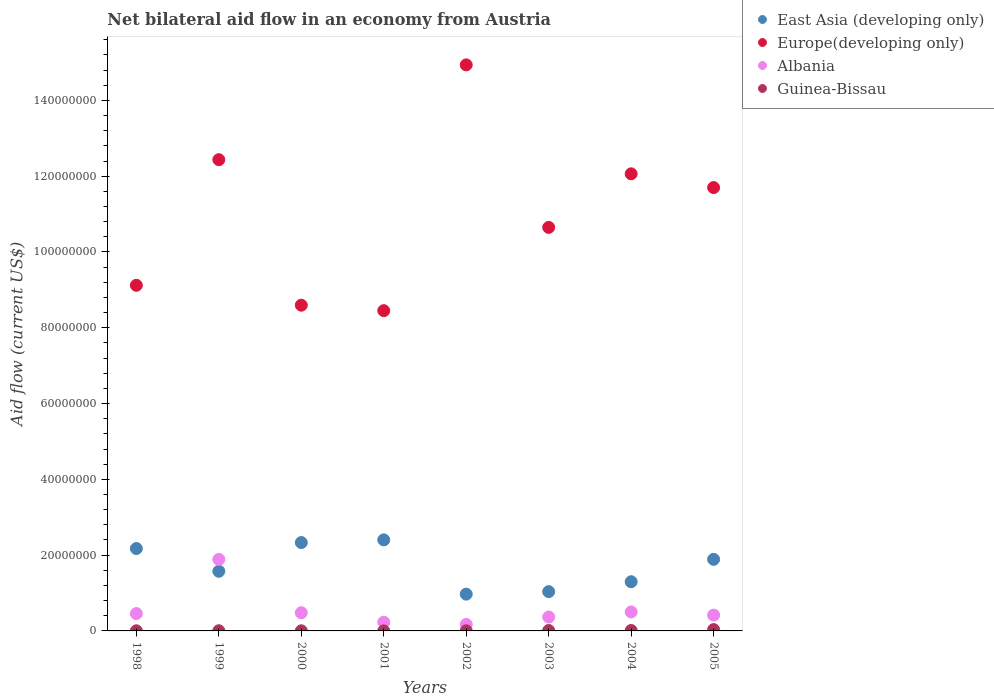How many different coloured dotlines are there?
Give a very brief answer. 4. Is the number of dotlines equal to the number of legend labels?
Ensure brevity in your answer.  Yes. What is the net bilateral aid flow in Guinea-Bissau in 2000?
Give a very brief answer. 3.00e+04. Across all years, what is the maximum net bilateral aid flow in Guinea-Bissau?
Your response must be concise. 3.50e+05. Across all years, what is the minimum net bilateral aid flow in Europe(developing only)?
Ensure brevity in your answer.  8.45e+07. In which year was the net bilateral aid flow in Guinea-Bissau maximum?
Keep it short and to the point. 2005. In which year was the net bilateral aid flow in East Asia (developing only) minimum?
Your answer should be compact. 2002. What is the total net bilateral aid flow in East Asia (developing only) in the graph?
Give a very brief answer. 1.37e+08. What is the difference between the net bilateral aid flow in Albania in 2003 and that in 2004?
Your response must be concise. -1.34e+06. What is the difference between the net bilateral aid flow in East Asia (developing only) in 2004 and the net bilateral aid flow in Europe(developing only) in 2002?
Make the answer very short. -1.36e+08. What is the average net bilateral aid flow in East Asia (developing only) per year?
Your response must be concise. 1.71e+07. In the year 2003, what is the difference between the net bilateral aid flow in Guinea-Bissau and net bilateral aid flow in Albania?
Your answer should be very brief. -3.56e+06. In how many years, is the net bilateral aid flow in East Asia (developing only) greater than 40000000 US$?
Give a very brief answer. 0. What is the ratio of the net bilateral aid flow in Europe(developing only) in 1999 to that in 2005?
Offer a very short reply. 1.06. Is the difference between the net bilateral aid flow in Guinea-Bissau in 2000 and 2001 greater than the difference between the net bilateral aid flow in Albania in 2000 and 2001?
Your answer should be compact. No. What is the difference between the highest and the second highest net bilateral aid flow in East Asia (developing only)?
Provide a short and direct response. 7.10e+05. What is the difference between the highest and the lowest net bilateral aid flow in Albania?
Make the answer very short. 1.72e+07. In how many years, is the net bilateral aid flow in Europe(developing only) greater than the average net bilateral aid flow in Europe(developing only) taken over all years?
Keep it short and to the point. 4. Is the sum of the net bilateral aid flow in Albania in 2001 and 2002 greater than the maximum net bilateral aid flow in East Asia (developing only) across all years?
Ensure brevity in your answer.  No. Is it the case that in every year, the sum of the net bilateral aid flow in East Asia (developing only) and net bilateral aid flow in Europe(developing only)  is greater than the sum of net bilateral aid flow in Guinea-Bissau and net bilateral aid flow in Albania?
Provide a succinct answer. Yes. Is it the case that in every year, the sum of the net bilateral aid flow in Albania and net bilateral aid flow in East Asia (developing only)  is greater than the net bilateral aid flow in Guinea-Bissau?
Make the answer very short. Yes. Does the net bilateral aid flow in Europe(developing only) monotonically increase over the years?
Offer a terse response. No. Is the net bilateral aid flow in Albania strictly greater than the net bilateral aid flow in Europe(developing only) over the years?
Offer a very short reply. No. Is the net bilateral aid flow in Albania strictly less than the net bilateral aid flow in Europe(developing only) over the years?
Ensure brevity in your answer.  Yes. How many years are there in the graph?
Your answer should be compact. 8. What is the difference between two consecutive major ticks on the Y-axis?
Make the answer very short. 2.00e+07. Does the graph contain any zero values?
Offer a very short reply. No. Does the graph contain grids?
Offer a very short reply. No. Where does the legend appear in the graph?
Make the answer very short. Top right. How many legend labels are there?
Your answer should be compact. 4. What is the title of the graph?
Provide a short and direct response. Net bilateral aid flow in an economy from Austria. What is the label or title of the X-axis?
Your answer should be compact. Years. What is the Aid flow (current US$) of East Asia (developing only) in 1998?
Provide a short and direct response. 2.17e+07. What is the Aid flow (current US$) of Europe(developing only) in 1998?
Offer a very short reply. 9.12e+07. What is the Aid flow (current US$) of Albania in 1998?
Provide a succinct answer. 4.58e+06. What is the Aid flow (current US$) of Guinea-Bissau in 1998?
Provide a succinct answer. 3.00e+04. What is the Aid flow (current US$) in East Asia (developing only) in 1999?
Provide a succinct answer. 1.57e+07. What is the Aid flow (current US$) of Europe(developing only) in 1999?
Offer a very short reply. 1.24e+08. What is the Aid flow (current US$) in Albania in 1999?
Offer a very short reply. 1.89e+07. What is the Aid flow (current US$) of Guinea-Bissau in 1999?
Offer a very short reply. 5.00e+04. What is the Aid flow (current US$) of East Asia (developing only) in 2000?
Give a very brief answer. 2.33e+07. What is the Aid flow (current US$) in Europe(developing only) in 2000?
Keep it short and to the point. 8.60e+07. What is the Aid flow (current US$) in Albania in 2000?
Provide a short and direct response. 4.80e+06. What is the Aid flow (current US$) of East Asia (developing only) in 2001?
Your answer should be compact. 2.40e+07. What is the Aid flow (current US$) of Europe(developing only) in 2001?
Provide a short and direct response. 8.45e+07. What is the Aid flow (current US$) in Albania in 2001?
Offer a very short reply. 2.30e+06. What is the Aid flow (current US$) in East Asia (developing only) in 2002?
Your response must be concise. 9.71e+06. What is the Aid flow (current US$) of Europe(developing only) in 2002?
Your answer should be compact. 1.49e+08. What is the Aid flow (current US$) of Albania in 2002?
Keep it short and to the point. 1.71e+06. What is the Aid flow (current US$) of East Asia (developing only) in 2003?
Your answer should be compact. 1.04e+07. What is the Aid flow (current US$) of Europe(developing only) in 2003?
Provide a short and direct response. 1.06e+08. What is the Aid flow (current US$) in Albania in 2003?
Offer a terse response. 3.67e+06. What is the Aid flow (current US$) in Guinea-Bissau in 2003?
Your response must be concise. 1.10e+05. What is the Aid flow (current US$) of East Asia (developing only) in 2004?
Keep it short and to the point. 1.30e+07. What is the Aid flow (current US$) in Europe(developing only) in 2004?
Offer a terse response. 1.21e+08. What is the Aid flow (current US$) of Albania in 2004?
Keep it short and to the point. 5.01e+06. What is the Aid flow (current US$) of East Asia (developing only) in 2005?
Your response must be concise. 1.89e+07. What is the Aid flow (current US$) in Europe(developing only) in 2005?
Keep it short and to the point. 1.17e+08. What is the Aid flow (current US$) in Albania in 2005?
Your answer should be very brief. 4.18e+06. Across all years, what is the maximum Aid flow (current US$) of East Asia (developing only)?
Provide a short and direct response. 2.40e+07. Across all years, what is the maximum Aid flow (current US$) in Europe(developing only)?
Give a very brief answer. 1.49e+08. Across all years, what is the maximum Aid flow (current US$) of Albania?
Provide a succinct answer. 1.89e+07. Across all years, what is the minimum Aid flow (current US$) of East Asia (developing only)?
Offer a terse response. 9.71e+06. Across all years, what is the minimum Aid flow (current US$) in Europe(developing only)?
Make the answer very short. 8.45e+07. Across all years, what is the minimum Aid flow (current US$) of Albania?
Provide a succinct answer. 1.71e+06. What is the total Aid flow (current US$) in East Asia (developing only) in the graph?
Provide a succinct answer. 1.37e+08. What is the total Aid flow (current US$) of Europe(developing only) in the graph?
Provide a short and direct response. 8.80e+08. What is the total Aid flow (current US$) of Albania in the graph?
Your response must be concise. 4.51e+07. What is the total Aid flow (current US$) in Guinea-Bissau in the graph?
Your answer should be very brief. 7.30e+05. What is the difference between the Aid flow (current US$) in East Asia (developing only) in 1998 and that in 1999?
Keep it short and to the point. 6.00e+06. What is the difference between the Aid flow (current US$) in Europe(developing only) in 1998 and that in 1999?
Provide a short and direct response. -3.32e+07. What is the difference between the Aid flow (current US$) of Albania in 1998 and that in 1999?
Your answer should be compact. -1.43e+07. What is the difference between the Aid flow (current US$) in East Asia (developing only) in 1998 and that in 2000?
Ensure brevity in your answer.  -1.58e+06. What is the difference between the Aid flow (current US$) in Europe(developing only) in 1998 and that in 2000?
Offer a very short reply. 5.25e+06. What is the difference between the Aid flow (current US$) of East Asia (developing only) in 1998 and that in 2001?
Keep it short and to the point. -2.29e+06. What is the difference between the Aid flow (current US$) in Europe(developing only) in 1998 and that in 2001?
Your answer should be very brief. 6.69e+06. What is the difference between the Aid flow (current US$) of Albania in 1998 and that in 2001?
Make the answer very short. 2.28e+06. What is the difference between the Aid flow (current US$) in Guinea-Bissau in 1998 and that in 2001?
Keep it short and to the point. 10000. What is the difference between the Aid flow (current US$) in East Asia (developing only) in 1998 and that in 2002?
Keep it short and to the point. 1.20e+07. What is the difference between the Aid flow (current US$) in Europe(developing only) in 1998 and that in 2002?
Provide a short and direct response. -5.82e+07. What is the difference between the Aid flow (current US$) of Albania in 1998 and that in 2002?
Your answer should be very brief. 2.87e+06. What is the difference between the Aid flow (current US$) of East Asia (developing only) in 1998 and that in 2003?
Provide a succinct answer. 1.14e+07. What is the difference between the Aid flow (current US$) of Europe(developing only) in 1998 and that in 2003?
Provide a short and direct response. -1.53e+07. What is the difference between the Aid flow (current US$) of Albania in 1998 and that in 2003?
Offer a very short reply. 9.10e+05. What is the difference between the Aid flow (current US$) in East Asia (developing only) in 1998 and that in 2004?
Ensure brevity in your answer.  8.76e+06. What is the difference between the Aid flow (current US$) of Europe(developing only) in 1998 and that in 2004?
Your response must be concise. -2.94e+07. What is the difference between the Aid flow (current US$) of Albania in 1998 and that in 2004?
Give a very brief answer. -4.30e+05. What is the difference between the Aid flow (current US$) in Guinea-Bissau in 1998 and that in 2004?
Give a very brief answer. -8.00e+04. What is the difference between the Aid flow (current US$) of East Asia (developing only) in 1998 and that in 2005?
Ensure brevity in your answer.  2.85e+06. What is the difference between the Aid flow (current US$) in Europe(developing only) in 1998 and that in 2005?
Give a very brief answer. -2.58e+07. What is the difference between the Aid flow (current US$) in Albania in 1998 and that in 2005?
Provide a short and direct response. 4.00e+05. What is the difference between the Aid flow (current US$) in Guinea-Bissau in 1998 and that in 2005?
Ensure brevity in your answer.  -3.20e+05. What is the difference between the Aid flow (current US$) of East Asia (developing only) in 1999 and that in 2000?
Ensure brevity in your answer.  -7.58e+06. What is the difference between the Aid flow (current US$) in Europe(developing only) in 1999 and that in 2000?
Your answer should be compact. 3.84e+07. What is the difference between the Aid flow (current US$) of Albania in 1999 and that in 2000?
Your answer should be very brief. 1.41e+07. What is the difference between the Aid flow (current US$) of East Asia (developing only) in 1999 and that in 2001?
Your answer should be compact. -8.29e+06. What is the difference between the Aid flow (current US$) of Europe(developing only) in 1999 and that in 2001?
Make the answer very short. 3.98e+07. What is the difference between the Aid flow (current US$) of Albania in 1999 and that in 2001?
Make the answer very short. 1.66e+07. What is the difference between the Aid flow (current US$) of Guinea-Bissau in 1999 and that in 2001?
Make the answer very short. 3.00e+04. What is the difference between the Aid flow (current US$) in East Asia (developing only) in 1999 and that in 2002?
Provide a short and direct response. 6.03e+06. What is the difference between the Aid flow (current US$) in Europe(developing only) in 1999 and that in 2002?
Your answer should be compact. -2.50e+07. What is the difference between the Aid flow (current US$) of Albania in 1999 and that in 2002?
Your response must be concise. 1.72e+07. What is the difference between the Aid flow (current US$) in Guinea-Bissau in 1999 and that in 2002?
Your answer should be compact. 2.00e+04. What is the difference between the Aid flow (current US$) of East Asia (developing only) in 1999 and that in 2003?
Give a very brief answer. 5.37e+06. What is the difference between the Aid flow (current US$) in Europe(developing only) in 1999 and that in 2003?
Offer a terse response. 1.79e+07. What is the difference between the Aid flow (current US$) of Albania in 1999 and that in 2003?
Keep it short and to the point. 1.52e+07. What is the difference between the Aid flow (current US$) of Guinea-Bissau in 1999 and that in 2003?
Give a very brief answer. -6.00e+04. What is the difference between the Aid flow (current US$) in East Asia (developing only) in 1999 and that in 2004?
Ensure brevity in your answer.  2.76e+06. What is the difference between the Aid flow (current US$) of Europe(developing only) in 1999 and that in 2004?
Offer a very short reply. 3.73e+06. What is the difference between the Aid flow (current US$) of Albania in 1999 and that in 2004?
Ensure brevity in your answer.  1.39e+07. What is the difference between the Aid flow (current US$) of East Asia (developing only) in 1999 and that in 2005?
Provide a short and direct response. -3.15e+06. What is the difference between the Aid flow (current US$) in Europe(developing only) in 1999 and that in 2005?
Your response must be concise. 7.36e+06. What is the difference between the Aid flow (current US$) in Albania in 1999 and that in 2005?
Keep it short and to the point. 1.47e+07. What is the difference between the Aid flow (current US$) of Guinea-Bissau in 1999 and that in 2005?
Give a very brief answer. -3.00e+05. What is the difference between the Aid flow (current US$) in East Asia (developing only) in 2000 and that in 2001?
Make the answer very short. -7.10e+05. What is the difference between the Aid flow (current US$) in Europe(developing only) in 2000 and that in 2001?
Offer a very short reply. 1.44e+06. What is the difference between the Aid flow (current US$) in Albania in 2000 and that in 2001?
Your answer should be very brief. 2.50e+06. What is the difference between the Aid flow (current US$) of Guinea-Bissau in 2000 and that in 2001?
Keep it short and to the point. 10000. What is the difference between the Aid flow (current US$) of East Asia (developing only) in 2000 and that in 2002?
Your response must be concise. 1.36e+07. What is the difference between the Aid flow (current US$) of Europe(developing only) in 2000 and that in 2002?
Give a very brief answer. -6.34e+07. What is the difference between the Aid flow (current US$) of Albania in 2000 and that in 2002?
Your response must be concise. 3.09e+06. What is the difference between the Aid flow (current US$) in Guinea-Bissau in 2000 and that in 2002?
Your answer should be compact. 0. What is the difference between the Aid flow (current US$) of East Asia (developing only) in 2000 and that in 2003?
Ensure brevity in your answer.  1.30e+07. What is the difference between the Aid flow (current US$) of Europe(developing only) in 2000 and that in 2003?
Provide a succinct answer. -2.05e+07. What is the difference between the Aid flow (current US$) in Albania in 2000 and that in 2003?
Your response must be concise. 1.13e+06. What is the difference between the Aid flow (current US$) in Guinea-Bissau in 2000 and that in 2003?
Keep it short and to the point. -8.00e+04. What is the difference between the Aid flow (current US$) in East Asia (developing only) in 2000 and that in 2004?
Provide a short and direct response. 1.03e+07. What is the difference between the Aid flow (current US$) in Europe(developing only) in 2000 and that in 2004?
Provide a short and direct response. -3.47e+07. What is the difference between the Aid flow (current US$) in Guinea-Bissau in 2000 and that in 2004?
Keep it short and to the point. -8.00e+04. What is the difference between the Aid flow (current US$) in East Asia (developing only) in 2000 and that in 2005?
Keep it short and to the point. 4.43e+06. What is the difference between the Aid flow (current US$) of Europe(developing only) in 2000 and that in 2005?
Offer a terse response. -3.10e+07. What is the difference between the Aid flow (current US$) in Albania in 2000 and that in 2005?
Keep it short and to the point. 6.20e+05. What is the difference between the Aid flow (current US$) of Guinea-Bissau in 2000 and that in 2005?
Ensure brevity in your answer.  -3.20e+05. What is the difference between the Aid flow (current US$) in East Asia (developing only) in 2001 and that in 2002?
Give a very brief answer. 1.43e+07. What is the difference between the Aid flow (current US$) of Europe(developing only) in 2001 and that in 2002?
Offer a very short reply. -6.49e+07. What is the difference between the Aid flow (current US$) in Albania in 2001 and that in 2002?
Give a very brief answer. 5.90e+05. What is the difference between the Aid flow (current US$) of Guinea-Bissau in 2001 and that in 2002?
Offer a very short reply. -10000. What is the difference between the Aid flow (current US$) of East Asia (developing only) in 2001 and that in 2003?
Ensure brevity in your answer.  1.37e+07. What is the difference between the Aid flow (current US$) of Europe(developing only) in 2001 and that in 2003?
Give a very brief answer. -2.20e+07. What is the difference between the Aid flow (current US$) in Albania in 2001 and that in 2003?
Your answer should be very brief. -1.37e+06. What is the difference between the Aid flow (current US$) in East Asia (developing only) in 2001 and that in 2004?
Provide a succinct answer. 1.10e+07. What is the difference between the Aid flow (current US$) of Europe(developing only) in 2001 and that in 2004?
Provide a succinct answer. -3.61e+07. What is the difference between the Aid flow (current US$) of Albania in 2001 and that in 2004?
Provide a short and direct response. -2.71e+06. What is the difference between the Aid flow (current US$) of Guinea-Bissau in 2001 and that in 2004?
Your answer should be very brief. -9.00e+04. What is the difference between the Aid flow (current US$) of East Asia (developing only) in 2001 and that in 2005?
Your answer should be very brief. 5.14e+06. What is the difference between the Aid flow (current US$) of Europe(developing only) in 2001 and that in 2005?
Keep it short and to the point. -3.25e+07. What is the difference between the Aid flow (current US$) in Albania in 2001 and that in 2005?
Ensure brevity in your answer.  -1.88e+06. What is the difference between the Aid flow (current US$) in Guinea-Bissau in 2001 and that in 2005?
Make the answer very short. -3.30e+05. What is the difference between the Aid flow (current US$) in East Asia (developing only) in 2002 and that in 2003?
Your response must be concise. -6.60e+05. What is the difference between the Aid flow (current US$) of Europe(developing only) in 2002 and that in 2003?
Your answer should be very brief. 4.29e+07. What is the difference between the Aid flow (current US$) in Albania in 2002 and that in 2003?
Your answer should be very brief. -1.96e+06. What is the difference between the Aid flow (current US$) in East Asia (developing only) in 2002 and that in 2004?
Your response must be concise. -3.27e+06. What is the difference between the Aid flow (current US$) in Europe(developing only) in 2002 and that in 2004?
Ensure brevity in your answer.  2.88e+07. What is the difference between the Aid flow (current US$) of Albania in 2002 and that in 2004?
Make the answer very short. -3.30e+06. What is the difference between the Aid flow (current US$) in East Asia (developing only) in 2002 and that in 2005?
Provide a succinct answer. -9.18e+06. What is the difference between the Aid flow (current US$) of Europe(developing only) in 2002 and that in 2005?
Give a very brief answer. 3.24e+07. What is the difference between the Aid flow (current US$) in Albania in 2002 and that in 2005?
Ensure brevity in your answer.  -2.47e+06. What is the difference between the Aid flow (current US$) in Guinea-Bissau in 2002 and that in 2005?
Your answer should be very brief. -3.20e+05. What is the difference between the Aid flow (current US$) of East Asia (developing only) in 2003 and that in 2004?
Your answer should be compact. -2.61e+06. What is the difference between the Aid flow (current US$) in Europe(developing only) in 2003 and that in 2004?
Keep it short and to the point. -1.41e+07. What is the difference between the Aid flow (current US$) of Albania in 2003 and that in 2004?
Make the answer very short. -1.34e+06. What is the difference between the Aid flow (current US$) in East Asia (developing only) in 2003 and that in 2005?
Offer a very short reply. -8.52e+06. What is the difference between the Aid flow (current US$) in Europe(developing only) in 2003 and that in 2005?
Make the answer very short. -1.05e+07. What is the difference between the Aid flow (current US$) of Albania in 2003 and that in 2005?
Provide a short and direct response. -5.10e+05. What is the difference between the Aid flow (current US$) of Guinea-Bissau in 2003 and that in 2005?
Offer a very short reply. -2.40e+05. What is the difference between the Aid flow (current US$) in East Asia (developing only) in 2004 and that in 2005?
Ensure brevity in your answer.  -5.91e+06. What is the difference between the Aid flow (current US$) in Europe(developing only) in 2004 and that in 2005?
Offer a terse response. 3.63e+06. What is the difference between the Aid flow (current US$) of Albania in 2004 and that in 2005?
Provide a short and direct response. 8.30e+05. What is the difference between the Aid flow (current US$) of Guinea-Bissau in 2004 and that in 2005?
Offer a terse response. -2.40e+05. What is the difference between the Aid flow (current US$) of East Asia (developing only) in 1998 and the Aid flow (current US$) of Europe(developing only) in 1999?
Offer a very short reply. -1.03e+08. What is the difference between the Aid flow (current US$) in East Asia (developing only) in 1998 and the Aid flow (current US$) in Albania in 1999?
Offer a terse response. 2.86e+06. What is the difference between the Aid flow (current US$) in East Asia (developing only) in 1998 and the Aid flow (current US$) in Guinea-Bissau in 1999?
Ensure brevity in your answer.  2.17e+07. What is the difference between the Aid flow (current US$) in Europe(developing only) in 1998 and the Aid flow (current US$) in Albania in 1999?
Your answer should be very brief. 7.23e+07. What is the difference between the Aid flow (current US$) in Europe(developing only) in 1998 and the Aid flow (current US$) in Guinea-Bissau in 1999?
Your answer should be compact. 9.12e+07. What is the difference between the Aid flow (current US$) in Albania in 1998 and the Aid flow (current US$) in Guinea-Bissau in 1999?
Your answer should be compact. 4.53e+06. What is the difference between the Aid flow (current US$) of East Asia (developing only) in 1998 and the Aid flow (current US$) of Europe(developing only) in 2000?
Give a very brief answer. -6.42e+07. What is the difference between the Aid flow (current US$) in East Asia (developing only) in 1998 and the Aid flow (current US$) in Albania in 2000?
Give a very brief answer. 1.69e+07. What is the difference between the Aid flow (current US$) in East Asia (developing only) in 1998 and the Aid flow (current US$) in Guinea-Bissau in 2000?
Provide a succinct answer. 2.17e+07. What is the difference between the Aid flow (current US$) of Europe(developing only) in 1998 and the Aid flow (current US$) of Albania in 2000?
Provide a short and direct response. 8.64e+07. What is the difference between the Aid flow (current US$) of Europe(developing only) in 1998 and the Aid flow (current US$) of Guinea-Bissau in 2000?
Make the answer very short. 9.12e+07. What is the difference between the Aid flow (current US$) of Albania in 1998 and the Aid flow (current US$) of Guinea-Bissau in 2000?
Your answer should be compact. 4.55e+06. What is the difference between the Aid flow (current US$) in East Asia (developing only) in 1998 and the Aid flow (current US$) in Europe(developing only) in 2001?
Ensure brevity in your answer.  -6.28e+07. What is the difference between the Aid flow (current US$) of East Asia (developing only) in 1998 and the Aid flow (current US$) of Albania in 2001?
Give a very brief answer. 1.94e+07. What is the difference between the Aid flow (current US$) in East Asia (developing only) in 1998 and the Aid flow (current US$) in Guinea-Bissau in 2001?
Keep it short and to the point. 2.17e+07. What is the difference between the Aid flow (current US$) in Europe(developing only) in 1998 and the Aid flow (current US$) in Albania in 2001?
Your answer should be very brief. 8.89e+07. What is the difference between the Aid flow (current US$) in Europe(developing only) in 1998 and the Aid flow (current US$) in Guinea-Bissau in 2001?
Offer a very short reply. 9.12e+07. What is the difference between the Aid flow (current US$) in Albania in 1998 and the Aid flow (current US$) in Guinea-Bissau in 2001?
Make the answer very short. 4.56e+06. What is the difference between the Aid flow (current US$) in East Asia (developing only) in 1998 and the Aid flow (current US$) in Europe(developing only) in 2002?
Keep it short and to the point. -1.28e+08. What is the difference between the Aid flow (current US$) in East Asia (developing only) in 1998 and the Aid flow (current US$) in Albania in 2002?
Ensure brevity in your answer.  2.00e+07. What is the difference between the Aid flow (current US$) of East Asia (developing only) in 1998 and the Aid flow (current US$) of Guinea-Bissau in 2002?
Your answer should be compact. 2.17e+07. What is the difference between the Aid flow (current US$) in Europe(developing only) in 1998 and the Aid flow (current US$) in Albania in 2002?
Offer a terse response. 8.95e+07. What is the difference between the Aid flow (current US$) in Europe(developing only) in 1998 and the Aid flow (current US$) in Guinea-Bissau in 2002?
Ensure brevity in your answer.  9.12e+07. What is the difference between the Aid flow (current US$) in Albania in 1998 and the Aid flow (current US$) in Guinea-Bissau in 2002?
Your answer should be very brief. 4.55e+06. What is the difference between the Aid flow (current US$) of East Asia (developing only) in 1998 and the Aid flow (current US$) of Europe(developing only) in 2003?
Offer a terse response. -8.48e+07. What is the difference between the Aid flow (current US$) in East Asia (developing only) in 1998 and the Aid flow (current US$) in Albania in 2003?
Offer a terse response. 1.81e+07. What is the difference between the Aid flow (current US$) in East Asia (developing only) in 1998 and the Aid flow (current US$) in Guinea-Bissau in 2003?
Provide a succinct answer. 2.16e+07. What is the difference between the Aid flow (current US$) of Europe(developing only) in 1998 and the Aid flow (current US$) of Albania in 2003?
Your response must be concise. 8.75e+07. What is the difference between the Aid flow (current US$) in Europe(developing only) in 1998 and the Aid flow (current US$) in Guinea-Bissau in 2003?
Provide a short and direct response. 9.11e+07. What is the difference between the Aid flow (current US$) in Albania in 1998 and the Aid flow (current US$) in Guinea-Bissau in 2003?
Provide a short and direct response. 4.47e+06. What is the difference between the Aid flow (current US$) of East Asia (developing only) in 1998 and the Aid flow (current US$) of Europe(developing only) in 2004?
Give a very brief answer. -9.89e+07. What is the difference between the Aid flow (current US$) of East Asia (developing only) in 1998 and the Aid flow (current US$) of Albania in 2004?
Your answer should be compact. 1.67e+07. What is the difference between the Aid flow (current US$) of East Asia (developing only) in 1998 and the Aid flow (current US$) of Guinea-Bissau in 2004?
Your answer should be very brief. 2.16e+07. What is the difference between the Aid flow (current US$) of Europe(developing only) in 1998 and the Aid flow (current US$) of Albania in 2004?
Your response must be concise. 8.62e+07. What is the difference between the Aid flow (current US$) in Europe(developing only) in 1998 and the Aid flow (current US$) in Guinea-Bissau in 2004?
Offer a very short reply. 9.11e+07. What is the difference between the Aid flow (current US$) in Albania in 1998 and the Aid flow (current US$) in Guinea-Bissau in 2004?
Provide a succinct answer. 4.47e+06. What is the difference between the Aid flow (current US$) of East Asia (developing only) in 1998 and the Aid flow (current US$) of Europe(developing only) in 2005?
Your response must be concise. -9.53e+07. What is the difference between the Aid flow (current US$) in East Asia (developing only) in 1998 and the Aid flow (current US$) in Albania in 2005?
Your answer should be compact. 1.76e+07. What is the difference between the Aid flow (current US$) in East Asia (developing only) in 1998 and the Aid flow (current US$) in Guinea-Bissau in 2005?
Provide a succinct answer. 2.14e+07. What is the difference between the Aid flow (current US$) of Europe(developing only) in 1998 and the Aid flow (current US$) of Albania in 2005?
Your response must be concise. 8.70e+07. What is the difference between the Aid flow (current US$) of Europe(developing only) in 1998 and the Aid flow (current US$) of Guinea-Bissau in 2005?
Provide a short and direct response. 9.09e+07. What is the difference between the Aid flow (current US$) of Albania in 1998 and the Aid flow (current US$) of Guinea-Bissau in 2005?
Your answer should be very brief. 4.23e+06. What is the difference between the Aid flow (current US$) in East Asia (developing only) in 1999 and the Aid flow (current US$) in Europe(developing only) in 2000?
Give a very brief answer. -7.02e+07. What is the difference between the Aid flow (current US$) in East Asia (developing only) in 1999 and the Aid flow (current US$) in Albania in 2000?
Make the answer very short. 1.09e+07. What is the difference between the Aid flow (current US$) in East Asia (developing only) in 1999 and the Aid flow (current US$) in Guinea-Bissau in 2000?
Provide a short and direct response. 1.57e+07. What is the difference between the Aid flow (current US$) of Europe(developing only) in 1999 and the Aid flow (current US$) of Albania in 2000?
Your answer should be very brief. 1.20e+08. What is the difference between the Aid flow (current US$) of Europe(developing only) in 1999 and the Aid flow (current US$) of Guinea-Bissau in 2000?
Offer a very short reply. 1.24e+08. What is the difference between the Aid flow (current US$) of Albania in 1999 and the Aid flow (current US$) of Guinea-Bissau in 2000?
Give a very brief answer. 1.88e+07. What is the difference between the Aid flow (current US$) in East Asia (developing only) in 1999 and the Aid flow (current US$) in Europe(developing only) in 2001?
Give a very brief answer. -6.88e+07. What is the difference between the Aid flow (current US$) of East Asia (developing only) in 1999 and the Aid flow (current US$) of Albania in 2001?
Ensure brevity in your answer.  1.34e+07. What is the difference between the Aid flow (current US$) in East Asia (developing only) in 1999 and the Aid flow (current US$) in Guinea-Bissau in 2001?
Your response must be concise. 1.57e+07. What is the difference between the Aid flow (current US$) in Europe(developing only) in 1999 and the Aid flow (current US$) in Albania in 2001?
Offer a very short reply. 1.22e+08. What is the difference between the Aid flow (current US$) in Europe(developing only) in 1999 and the Aid flow (current US$) in Guinea-Bissau in 2001?
Give a very brief answer. 1.24e+08. What is the difference between the Aid flow (current US$) in Albania in 1999 and the Aid flow (current US$) in Guinea-Bissau in 2001?
Ensure brevity in your answer.  1.89e+07. What is the difference between the Aid flow (current US$) in East Asia (developing only) in 1999 and the Aid flow (current US$) in Europe(developing only) in 2002?
Give a very brief answer. -1.34e+08. What is the difference between the Aid flow (current US$) of East Asia (developing only) in 1999 and the Aid flow (current US$) of Albania in 2002?
Provide a succinct answer. 1.40e+07. What is the difference between the Aid flow (current US$) of East Asia (developing only) in 1999 and the Aid flow (current US$) of Guinea-Bissau in 2002?
Ensure brevity in your answer.  1.57e+07. What is the difference between the Aid flow (current US$) in Europe(developing only) in 1999 and the Aid flow (current US$) in Albania in 2002?
Offer a very short reply. 1.23e+08. What is the difference between the Aid flow (current US$) in Europe(developing only) in 1999 and the Aid flow (current US$) in Guinea-Bissau in 2002?
Offer a very short reply. 1.24e+08. What is the difference between the Aid flow (current US$) in Albania in 1999 and the Aid flow (current US$) in Guinea-Bissau in 2002?
Provide a short and direct response. 1.88e+07. What is the difference between the Aid flow (current US$) of East Asia (developing only) in 1999 and the Aid flow (current US$) of Europe(developing only) in 2003?
Ensure brevity in your answer.  -9.08e+07. What is the difference between the Aid flow (current US$) in East Asia (developing only) in 1999 and the Aid flow (current US$) in Albania in 2003?
Your answer should be compact. 1.21e+07. What is the difference between the Aid flow (current US$) in East Asia (developing only) in 1999 and the Aid flow (current US$) in Guinea-Bissau in 2003?
Your answer should be compact. 1.56e+07. What is the difference between the Aid flow (current US$) of Europe(developing only) in 1999 and the Aid flow (current US$) of Albania in 2003?
Your answer should be very brief. 1.21e+08. What is the difference between the Aid flow (current US$) of Europe(developing only) in 1999 and the Aid flow (current US$) of Guinea-Bissau in 2003?
Keep it short and to the point. 1.24e+08. What is the difference between the Aid flow (current US$) in Albania in 1999 and the Aid flow (current US$) in Guinea-Bissau in 2003?
Your response must be concise. 1.88e+07. What is the difference between the Aid flow (current US$) of East Asia (developing only) in 1999 and the Aid flow (current US$) of Europe(developing only) in 2004?
Give a very brief answer. -1.05e+08. What is the difference between the Aid flow (current US$) of East Asia (developing only) in 1999 and the Aid flow (current US$) of Albania in 2004?
Offer a very short reply. 1.07e+07. What is the difference between the Aid flow (current US$) in East Asia (developing only) in 1999 and the Aid flow (current US$) in Guinea-Bissau in 2004?
Offer a terse response. 1.56e+07. What is the difference between the Aid flow (current US$) in Europe(developing only) in 1999 and the Aid flow (current US$) in Albania in 2004?
Keep it short and to the point. 1.19e+08. What is the difference between the Aid flow (current US$) of Europe(developing only) in 1999 and the Aid flow (current US$) of Guinea-Bissau in 2004?
Give a very brief answer. 1.24e+08. What is the difference between the Aid flow (current US$) of Albania in 1999 and the Aid flow (current US$) of Guinea-Bissau in 2004?
Provide a succinct answer. 1.88e+07. What is the difference between the Aid flow (current US$) in East Asia (developing only) in 1999 and the Aid flow (current US$) in Europe(developing only) in 2005?
Offer a very short reply. -1.01e+08. What is the difference between the Aid flow (current US$) of East Asia (developing only) in 1999 and the Aid flow (current US$) of Albania in 2005?
Keep it short and to the point. 1.16e+07. What is the difference between the Aid flow (current US$) of East Asia (developing only) in 1999 and the Aid flow (current US$) of Guinea-Bissau in 2005?
Offer a very short reply. 1.54e+07. What is the difference between the Aid flow (current US$) in Europe(developing only) in 1999 and the Aid flow (current US$) in Albania in 2005?
Make the answer very short. 1.20e+08. What is the difference between the Aid flow (current US$) in Europe(developing only) in 1999 and the Aid flow (current US$) in Guinea-Bissau in 2005?
Keep it short and to the point. 1.24e+08. What is the difference between the Aid flow (current US$) in Albania in 1999 and the Aid flow (current US$) in Guinea-Bissau in 2005?
Offer a very short reply. 1.85e+07. What is the difference between the Aid flow (current US$) in East Asia (developing only) in 2000 and the Aid flow (current US$) in Europe(developing only) in 2001?
Keep it short and to the point. -6.12e+07. What is the difference between the Aid flow (current US$) of East Asia (developing only) in 2000 and the Aid flow (current US$) of Albania in 2001?
Your response must be concise. 2.10e+07. What is the difference between the Aid flow (current US$) of East Asia (developing only) in 2000 and the Aid flow (current US$) of Guinea-Bissau in 2001?
Keep it short and to the point. 2.33e+07. What is the difference between the Aid flow (current US$) in Europe(developing only) in 2000 and the Aid flow (current US$) in Albania in 2001?
Your answer should be compact. 8.37e+07. What is the difference between the Aid flow (current US$) of Europe(developing only) in 2000 and the Aid flow (current US$) of Guinea-Bissau in 2001?
Keep it short and to the point. 8.59e+07. What is the difference between the Aid flow (current US$) in Albania in 2000 and the Aid flow (current US$) in Guinea-Bissau in 2001?
Your answer should be compact. 4.78e+06. What is the difference between the Aid flow (current US$) in East Asia (developing only) in 2000 and the Aid flow (current US$) in Europe(developing only) in 2002?
Offer a very short reply. -1.26e+08. What is the difference between the Aid flow (current US$) of East Asia (developing only) in 2000 and the Aid flow (current US$) of Albania in 2002?
Provide a short and direct response. 2.16e+07. What is the difference between the Aid flow (current US$) of East Asia (developing only) in 2000 and the Aid flow (current US$) of Guinea-Bissau in 2002?
Keep it short and to the point. 2.33e+07. What is the difference between the Aid flow (current US$) in Europe(developing only) in 2000 and the Aid flow (current US$) in Albania in 2002?
Provide a short and direct response. 8.42e+07. What is the difference between the Aid flow (current US$) in Europe(developing only) in 2000 and the Aid flow (current US$) in Guinea-Bissau in 2002?
Your response must be concise. 8.59e+07. What is the difference between the Aid flow (current US$) of Albania in 2000 and the Aid flow (current US$) of Guinea-Bissau in 2002?
Offer a very short reply. 4.77e+06. What is the difference between the Aid flow (current US$) of East Asia (developing only) in 2000 and the Aid flow (current US$) of Europe(developing only) in 2003?
Ensure brevity in your answer.  -8.32e+07. What is the difference between the Aid flow (current US$) of East Asia (developing only) in 2000 and the Aid flow (current US$) of Albania in 2003?
Keep it short and to the point. 1.96e+07. What is the difference between the Aid flow (current US$) of East Asia (developing only) in 2000 and the Aid flow (current US$) of Guinea-Bissau in 2003?
Provide a succinct answer. 2.32e+07. What is the difference between the Aid flow (current US$) in Europe(developing only) in 2000 and the Aid flow (current US$) in Albania in 2003?
Your answer should be very brief. 8.23e+07. What is the difference between the Aid flow (current US$) in Europe(developing only) in 2000 and the Aid flow (current US$) in Guinea-Bissau in 2003?
Give a very brief answer. 8.58e+07. What is the difference between the Aid flow (current US$) of Albania in 2000 and the Aid flow (current US$) of Guinea-Bissau in 2003?
Offer a very short reply. 4.69e+06. What is the difference between the Aid flow (current US$) in East Asia (developing only) in 2000 and the Aid flow (current US$) in Europe(developing only) in 2004?
Give a very brief answer. -9.73e+07. What is the difference between the Aid flow (current US$) of East Asia (developing only) in 2000 and the Aid flow (current US$) of Albania in 2004?
Your answer should be compact. 1.83e+07. What is the difference between the Aid flow (current US$) in East Asia (developing only) in 2000 and the Aid flow (current US$) in Guinea-Bissau in 2004?
Your answer should be compact. 2.32e+07. What is the difference between the Aid flow (current US$) of Europe(developing only) in 2000 and the Aid flow (current US$) of Albania in 2004?
Offer a very short reply. 8.10e+07. What is the difference between the Aid flow (current US$) in Europe(developing only) in 2000 and the Aid flow (current US$) in Guinea-Bissau in 2004?
Keep it short and to the point. 8.58e+07. What is the difference between the Aid flow (current US$) in Albania in 2000 and the Aid flow (current US$) in Guinea-Bissau in 2004?
Offer a terse response. 4.69e+06. What is the difference between the Aid flow (current US$) in East Asia (developing only) in 2000 and the Aid flow (current US$) in Europe(developing only) in 2005?
Offer a terse response. -9.37e+07. What is the difference between the Aid flow (current US$) in East Asia (developing only) in 2000 and the Aid flow (current US$) in Albania in 2005?
Your answer should be very brief. 1.91e+07. What is the difference between the Aid flow (current US$) in East Asia (developing only) in 2000 and the Aid flow (current US$) in Guinea-Bissau in 2005?
Your response must be concise. 2.30e+07. What is the difference between the Aid flow (current US$) of Europe(developing only) in 2000 and the Aid flow (current US$) of Albania in 2005?
Provide a succinct answer. 8.18e+07. What is the difference between the Aid flow (current US$) in Europe(developing only) in 2000 and the Aid flow (current US$) in Guinea-Bissau in 2005?
Provide a short and direct response. 8.56e+07. What is the difference between the Aid flow (current US$) in Albania in 2000 and the Aid flow (current US$) in Guinea-Bissau in 2005?
Offer a terse response. 4.45e+06. What is the difference between the Aid flow (current US$) of East Asia (developing only) in 2001 and the Aid flow (current US$) of Europe(developing only) in 2002?
Your answer should be compact. -1.25e+08. What is the difference between the Aid flow (current US$) in East Asia (developing only) in 2001 and the Aid flow (current US$) in Albania in 2002?
Offer a very short reply. 2.23e+07. What is the difference between the Aid flow (current US$) of East Asia (developing only) in 2001 and the Aid flow (current US$) of Guinea-Bissau in 2002?
Offer a very short reply. 2.40e+07. What is the difference between the Aid flow (current US$) of Europe(developing only) in 2001 and the Aid flow (current US$) of Albania in 2002?
Your response must be concise. 8.28e+07. What is the difference between the Aid flow (current US$) in Europe(developing only) in 2001 and the Aid flow (current US$) in Guinea-Bissau in 2002?
Ensure brevity in your answer.  8.45e+07. What is the difference between the Aid flow (current US$) in Albania in 2001 and the Aid flow (current US$) in Guinea-Bissau in 2002?
Give a very brief answer. 2.27e+06. What is the difference between the Aid flow (current US$) in East Asia (developing only) in 2001 and the Aid flow (current US$) in Europe(developing only) in 2003?
Your response must be concise. -8.25e+07. What is the difference between the Aid flow (current US$) of East Asia (developing only) in 2001 and the Aid flow (current US$) of Albania in 2003?
Your answer should be compact. 2.04e+07. What is the difference between the Aid flow (current US$) of East Asia (developing only) in 2001 and the Aid flow (current US$) of Guinea-Bissau in 2003?
Offer a very short reply. 2.39e+07. What is the difference between the Aid flow (current US$) of Europe(developing only) in 2001 and the Aid flow (current US$) of Albania in 2003?
Provide a short and direct response. 8.08e+07. What is the difference between the Aid flow (current US$) in Europe(developing only) in 2001 and the Aid flow (current US$) in Guinea-Bissau in 2003?
Keep it short and to the point. 8.44e+07. What is the difference between the Aid flow (current US$) in Albania in 2001 and the Aid flow (current US$) in Guinea-Bissau in 2003?
Your answer should be very brief. 2.19e+06. What is the difference between the Aid flow (current US$) in East Asia (developing only) in 2001 and the Aid flow (current US$) in Europe(developing only) in 2004?
Your answer should be very brief. -9.66e+07. What is the difference between the Aid flow (current US$) in East Asia (developing only) in 2001 and the Aid flow (current US$) in Albania in 2004?
Offer a very short reply. 1.90e+07. What is the difference between the Aid flow (current US$) of East Asia (developing only) in 2001 and the Aid flow (current US$) of Guinea-Bissau in 2004?
Offer a terse response. 2.39e+07. What is the difference between the Aid flow (current US$) of Europe(developing only) in 2001 and the Aid flow (current US$) of Albania in 2004?
Offer a very short reply. 7.95e+07. What is the difference between the Aid flow (current US$) in Europe(developing only) in 2001 and the Aid flow (current US$) in Guinea-Bissau in 2004?
Give a very brief answer. 8.44e+07. What is the difference between the Aid flow (current US$) of Albania in 2001 and the Aid flow (current US$) of Guinea-Bissau in 2004?
Make the answer very short. 2.19e+06. What is the difference between the Aid flow (current US$) of East Asia (developing only) in 2001 and the Aid flow (current US$) of Europe(developing only) in 2005?
Make the answer very short. -9.30e+07. What is the difference between the Aid flow (current US$) of East Asia (developing only) in 2001 and the Aid flow (current US$) of Albania in 2005?
Make the answer very short. 1.98e+07. What is the difference between the Aid flow (current US$) of East Asia (developing only) in 2001 and the Aid flow (current US$) of Guinea-Bissau in 2005?
Your response must be concise. 2.37e+07. What is the difference between the Aid flow (current US$) in Europe(developing only) in 2001 and the Aid flow (current US$) in Albania in 2005?
Give a very brief answer. 8.03e+07. What is the difference between the Aid flow (current US$) in Europe(developing only) in 2001 and the Aid flow (current US$) in Guinea-Bissau in 2005?
Offer a terse response. 8.42e+07. What is the difference between the Aid flow (current US$) in Albania in 2001 and the Aid flow (current US$) in Guinea-Bissau in 2005?
Give a very brief answer. 1.95e+06. What is the difference between the Aid flow (current US$) of East Asia (developing only) in 2002 and the Aid flow (current US$) of Europe(developing only) in 2003?
Your answer should be compact. -9.68e+07. What is the difference between the Aid flow (current US$) in East Asia (developing only) in 2002 and the Aid flow (current US$) in Albania in 2003?
Your answer should be compact. 6.04e+06. What is the difference between the Aid flow (current US$) of East Asia (developing only) in 2002 and the Aid flow (current US$) of Guinea-Bissau in 2003?
Offer a very short reply. 9.60e+06. What is the difference between the Aid flow (current US$) in Europe(developing only) in 2002 and the Aid flow (current US$) in Albania in 2003?
Give a very brief answer. 1.46e+08. What is the difference between the Aid flow (current US$) of Europe(developing only) in 2002 and the Aid flow (current US$) of Guinea-Bissau in 2003?
Provide a succinct answer. 1.49e+08. What is the difference between the Aid flow (current US$) in Albania in 2002 and the Aid flow (current US$) in Guinea-Bissau in 2003?
Your response must be concise. 1.60e+06. What is the difference between the Aid flow (current US$) in East Asia (developing only) in 2002 and the Aid flow (current US$) in Europe(developing only) in 2004?
Make the answer very short. -1.11e+08. What is the difference between the Aid flow (current US$) of East Asia (developing only) in 2002 and the Aid flow (current US$) of Albania in 2004?
Your answer should be compact. 4.70e+06. What is the difference between the Aid flow (current US$) in East Asia (developing only) in 2002 and the Aid flow (current US$) in Guinea-Bissau in 2004?
Offer a terse response. 9.60e+06. What is the difference between the Aid flow (current US$) in Europe(developing only) in 2002 and the Aid flow (current US$) in Albania in 2004?
Offer a terse response. 1.44e+08. What is the difference between the Aid flow (current US$) of Europe(developing only) in 2002 and the Aid flow (current US$) of Guinea-Bissau in 2004?
Offer a terse response. 1.49e+08. What is the difference between the Aid flow (current US$) in Albania in 2002 and the Aid flow (current US$) in Guinea-Bissau in 2004?
Provide a succinct answer. 1.60e+06. What is the difference between the Aid flow (current US$) in East Asia (developing only) in 2002 and the Aid flow (current US$) in Europe(developing only) in 2005?
Offer a terse response. -1.07e+08. What is the difference between the Aid flow (current US$) in East Asia (developing only) in 2002 and the Aid flow (current US$) in Albania in 2005?
Provide a short and direct response. 5.53e+06. What is the difference between the Aid flow (current US$) in East Asia (developing only) in 2002 and the Aid flow (current US$) in Guinea-Bissau in 2005?
Your answer should be very brief. 9.36e+06. What is the difference between the Aid flow (current US$) of Europe(developing only) in 2002 and the Aid flow (current US$) of Albania in 2005?
Keep it short and to the point. 1.45e+08. What is the difference between the Aid flow (current US$) in Europe(developing only) in 2002 and the Aid flow (current US$) in Guinea-Bissau in 2005?
Your response must be concise. 1.49e+08. What is the difference between the Aid flow (current US$) of Albania in 2002 and the Aid flow (current US$) of Guinea-Bissau in 2005?
Ensure brevity in your answer.  1.36e+06. What is the difference between the Aid flow (current US$) in East Asia (developing only) in 2003 and the Aid flow (current US$) in Europe(developing only) in 2004?
Provide a short and direct response. -1.10e+08. What is the difference between the Aid flow (current US$) of East Asia (developing only) in 2003 and the Aid flow (current US$) of Albania in 2004?
Offer a terse response. 5.36e+06. What is the difference between the Aid flow (current US$) of East Asia (developing only) in 2003 and the Aid flow (current US$) of Guinea-Bissau in 2004?
Offer a terse response. 1.03e+07. What is the difference between the Aid flow (current US$) of Europe(developing only) in 2003 and the Aid flow (current US$) of Albania in 2004?
Offer a very short reply. 1.01e+08. What is the difference between the Aid flow (current US$) of Europe(developing only) in 2003 and the Aid flow (current US$) of Guinea-Bissau in 2004?
Your answer should be compact. 1.06e+08. What is the difference between the Aid flow (current US$) of Albania in 2003 and the Aid flow (current US$) of Guinea-Bissau in 2004?
Provide a short and direct response. 3.56e+06. What is the difference between the Aid flow (current US$) of East Asia (developing only) in 2003 and the Aid flow (current US$) of Europe(developing only) in 2005?
Ensure brevity in your answer.  -1.07e+08. What is the difference between the Aid flow (current US$) of East Asia (developing only) in 2003 and the Aid flow (current US$) of Albania in 2005?
Your response must be concise. 6.19e+06. What is the difference between the Aid flow (current US$) of East Asia (developing only) in 2003 and the Aid flow (current US$) of Guinea-Bissau in 2005?
Provide a short and direct response. 1.00e+07. What is the difference between the Aid flow (current US$) in Europe(developing only) in 2003 and the Aid flow (current US$) in Albania in 2005?
Your answer should be compact. 1.02e+08. What is the difference between the Aid flow (current US$) in Europe(developing only) in 2003 and the Aid flow (current US$) in Guinea-Bissau in 2005?
Offer a very short reply. 1.06e+08. What is the difference between the Aid flow (current US$) of Albania in 2003 and the Aid flow (current US$) of Guinea-Bissau in 2005?
Your answer should be very brief. 3.32e+06. What is the difference between the Aid flow (current US$) in East Asia (developing only) in 2004 and the Aid flow (current US$) in Europe(developing only) in 2005?
Keep it short and to the point. -1.04e+08. What is the difference between the Aid flow (current US$) in East Asia (developing only) in 2004 and the Aid flow (current US$) in Albania in 2005?
Your answer should be compact. 8.80e+06. What is the difference between the Aid flow (current US$) of East Asia (developing only) in 2004 and the Aid flow (current US$) of Guinea-Bissau in 2005?
Offer a terse response. 1.26e+07. What is the difference between the Aid flow (current US$) in Europe(developing only) in 2004 and the Aid flow (current US$) in Albania in 2005?
Make the answer very short. 1.16e+08. What is the difference between the Aid flow (current US$) in Europe(developing only) in 2004 and the Aid flow (current US$) in Guinea-Bissau in 2005?
Your answer should be very brief. 1.20e+08. What is the difference between the Aid flow (current US$) of Albania in 2004 and the Aid flow (current US$) of Guinea-Bissau in 2005?
Offer a terse response. 4.66e+06. What is the average Aid flow (current US$) of East Asia (developing only) per year?
Your answer should be very brief. 1.71e+07. What is the average Aid flow (current US$) of Europe(developing only) per year?
Make the answer very short. 1.10e+08. What is the average Aid flow (current US$) of Albania per year?
Offer a very short reply. 5.64e+06. What is the average Aid flow (current US$) in Guinea-Bissau per year?
Keep it short and to the point. 9.12e+04. In the year 1998, what is the difference between the Aid flow (current US$) in East Asia (developing only) and Aid flow (current US$) in Europe(developing only)?
Your response must be concise. -6.95e+07. In the year 1998, what is the difference between the Aid flow (current US$) in East Asia (developing only) and Aid flow (current US$) in Albania?
Your response must be concise. 1.72e+07. In the year 1998, what is the difference between the Aid flow (current US$) of East Asia (developing only) and Aid flow (current US$) of Guinea-Bissau?
Ensure brevity in your answer.  2.17e+07. In the year 1998, what is the difference between the Aid flow (current US$) in Europe(developing only) and Aid flow (current US$) in Albania?
Your answer should be very brief. 8.66e+07. In the year 1998, what is the difference between the Aid flow (current US$) of Europe(developing only) and Aid flow (current US$) of Guinea-Bissau?
Provide a succinct answer. 9.12e+07. In the year 1998, what is the difference between the Aid flow (current US$) in Albania and Aid flow (current US$) in Guinea-Bissau?
Your answer should be compact. 4.55e+06. In the year 1999, what is the difference between the Aid flow (current US$) of East Asia (developing only) and Aid flow (current US$) of Europe(developing only)?
Keep it short and to the point. -1.09e+08. In the year 1999, what is the difference between the Aid flow (current US$) in East Asia (developing only) and Aid flow (current US$) in Albania?
Provide a succinct answer. -3.14e+06. In the year 1999, what is the difference between the Aid flow (current US$) in East Asia (developing only) and Aid flow (current US$) in Guinea-Bissau?
Your answer should be very brief. 1.57e+07. In the year 1999, what is the difference between the Aid flow (current US$) in Europe(developing only) and Aid flow (current US$) in Albania?
Provide a succinct answer. 1.05e+08. In the year 1999, what is the difference between the Aid flow (current US$) of Europe(developing only) and Aid flow (current US$) of Guinea-Bissau?
Provide a succinct answer. 1.24e+08. In the year 1999, what is the difference between the Aid flow (current US$) in Albania and Aid flow (current US$) in Guinea-Bissau?
Ensure brevity in your answer.  1.88e+07. In the year 2000, what is the difference between the Aid flow (current US$) in East Asia (developing only) and Aid flow (current US$) in Europe(developing only)?
Provide a succinct answer. -6.26e+07. In the year 2000, what is the difference between the Aid flow (current US$) of East Asia (developing only) and Aid flow (current US$) of Albania?
Offer a terse response. 1.85e+07. In the year 2000, what is the difference between the Aid flow (current US$) of East Asia (developing only) and Aid flow (current US$) of Guinea-Bissau?
Offer a terse response. 2.33e+07. In the year 2000, what is the difference between the Aid flow (current US$) of Europe(developing only) and Aid flow (current US$) of Albania?
Your answer should be compact. 8.12e+07. In the year 2000, what is the difference between the Aid flow (current US$) in Europe(developing only) and Aid flow (current US$) in Guinea-Bissau?
Your response must be concise. 8.59e+07. In the year 2000, what is the difference between the Aid flow (current US$) in Albania and Aid flow (current US$) in Guinea-Bissau?
Provide a succinct answer. 4.77e+06. In the year 2001, what is the difference between the Aid flow (current US$) in East Asia (developing only) and Aid flow (current US$) in Europe(developing only)?
Make the answer very short. -6.05e+07. In the year 2001, what is the difference between the Aid flow (current US$) of East Asia (developing only) and Aid flow (current US$) of Albania?
Give a very brief answer. 2.17e+07. In the year 2001, what is the difference between the Aid flow (current US$) of East Asia (developing only) and Aid flow (current US$) of Guinea-Bissau?
Your answer should be compact. 2.40e+07. In the year 2001, what is the difference between the Aid flow (current US$) in Europe(developing only) and Aid flow (current US$) in Albania?
Ensure brevity in your answer.  8.22e+07. In the year 2001, what is the difference between the Aid flow (current US$) in Europe(developing only) and Aid flow (current US$) in Guinea-Bissau?
Your answer should be compact. 8.45e+07. In the year 2001, what is the difference between the Aid flow (current US$) in Albania and Aid flow (current US$) in Guinea-Bissau?
Provide a short and direct response. 2.28e+06. In the year 2002, what is the difference between the Aid flow (current US$) in East Asia (developing only) and Aid flow (current US$) in Europe(developing only)?
Offer a terse response. -1.40e+08. In the year 2002, what is the difference between the Aid flow (current US$) of East Asia (developing only) and Aid flow (current US$) of Albania?
Your response must be concise. 8.00e+06. In the year 2002, what is the difference between the Aid flow (current US$) in East Asia (developing only) and Aid flow (current US$) in Guinea-Bissau?
Ensure brevity in your answer.  9.68e+06. In the year 2002, what is the difference between the Aid flow (current US$) in Europe(developing only) and Aid flow (current US$) in Albania?
Your answer should be compact. 1.48e+08. In the year 2002, what is the difference between the Aid flow (current US$) in Europe(developing only) and Aid flow (current US$) in Guinea-Bissau?
Offer a terse response. 1.49e+08. In the year 2002, what is the difference between the Aid flow (current US$) in Albania and Aid flow (current US$) in Guinea-Bissau?
Give a very brief answer. 1.68e+06. In the year 2003, what is the difference between the Aid flow (current US$) of East Asia (developing only) and Aid flow (current US$) of Europe(developing only)?
Your answer should be very brief. -9.61e+07. In the year 2003, what is the difference between the Aid flow (current US$) of East Asia (developing only) and Aid flow (current US$) of Albania?
Your answer should be compact. 6.70e+06. In the year 2003, what is the difference between the Aid flow (current US$) of East Asia (developing only) and Aid flow (current US$) of Guinea-Bissau?
Offer a terse response. 1.03e+07. In the year 2003, what is the difference between the Aid flow (current US$) in Europe(developing only) and Aid flow (current US$) in Albania?
Ensure brevity in your answer.  1.03e+08. In the year 2003, what is the difference between the Aid flow (current US$) of Europe(developing only) and Aid flow (current US$) of Guinea-Bissau?
Provide a succinct answer. 1.06e+08. In the year 2003, what is the difference between the Aid flow (current US$) in Albania and Aid flow (current US$) in Guinea-Bissau?
Make the answer very short. 3.56e+06. In the year 2004, what is the difference between the Aid flow (current US$) in East Asia (developing only) and Aid flow (current US$) in Europe(developing only)?
Provide a short and direct response. -1.08e+08. In the year 2004, what is the difference between the Aid flow (current US$) of East Asia (developing only) and Aid flow (current US$) of Albania?
Make the answer very short. 7.97e+06. In the year 2004, what is the difference between the Aid flow (current US$) of East Asia (developing only) and Aid flow (current US$) of Guinea-Bissau?
Your answer should be very brief. 1.29e+07. In the year 2004, what is the difference between the Aid flow (current US$) of Europe(developing only) and Aid flow (current US$) of Albania?
Ensure brevity in your answer.  1.16e+08. In the year 2004, what is the difference between the Aid flow (current US$) in Europe(developing only) and Aid flow (current US$) in Guinea-Bissau?
Ensure brevity in your answer.  1.21e+08. In the year 2004, what is the difference between the Aid flow (current US$) in Albania and Aid flow (current US$) in Guinea-Bissau?
Make the answer very short. 4.90e+06. In the year 2005, what is the difference between the Aid flow (current US$) of East Asia (developing only) and Aid flow (current US$) of Europe(developing only)?
Provide a short and direct response. -9.81e+07. In the year 2005, what is the difference between the Aid flow (current US$) of East Asia (developing only) and Aid flow (current US$) of Albania?
Provide a short and direct response. 1.47e+07. In the year 2005, what is the difference between the Aid flow (current US$) in East Asia (developing only) and Aid flow (current US$) in Guinea-Bissau?
Your response must be concise. 1.85e+07. In the year 2005, what is the difference between the Aid flow (current US$) in Europe(developing only) and Aid flow (current US$) in Albania?
Your response must be concise. 1.13e+08. In the year 2005, what is the difference between the Aid flow (current US$) in Europe(developing only) and Aid flow (current US$) in Guinea-Bissau?
Provide a succinct answer. 1.17e+08. In the year 2005, what is the difference between the Aid flow (current US$) in Albania and Aid flow (current US$) in Guinea-Bissau?
Make the answer very short. 3.83e+06. What is the ratio of the Aid flow (current US$) in East Asia (developing only) in 1998 to that in 1999?
Offer a terse response. 1.38. What is the ratio of the Aid flow (current US$) of Europe(developing only) in 1998 to that in 1999?
Make the answer very short. 0.73. What is the ratio of the Aid flow (current US$) of Albania in 1998 to that in 1999?
Offer a terse response. 0.24. What is the ratio of the Aid flow (current US$) of Guinea-Bissau in 1998 to that in 1999?
Provide a succinct answer. 0.6. What is the ratio of the Aid flow (current US$) of East Asia (developing only) in 1998 to that in 2000?
Your response must be concise. 0.93. What is the ratio of the Aid flow (current US$) of Europe(developing only) in 1998 to that in 2000?
Your answer should be compact. 1.06. What is the ratio of the Aid flow (current US$) in Albania in 1998 to that in 2000?
Your answer should be very brief. 0.95. What is the ratio of the Aid flow (current US$) in East Asia (developing only) in 1998 to that in 2001?
Your answer should be very brief. 0.9. What is the ratio of the Aid flow (current US$) of Europe(developing only) in 1998 to that in 2001?
Ensure brevity in your answer.  1.08. What is the ratio of the Aid flow (current US$) in Albania in 1998 to that in 2001?
Keep it short and to the point. 1.99. What is the ratio of the Aid flow (current US$) of Guinea-Bissau in 1998 to that in 2001?
Provide a succinct answer. 1.5. What is the ratio of the Aid flow (current US$) of East Asia (developing only) in 1998 to that in 2002?
Your answer should be very brief. 2.24. What is the ratio of the Aid flow (current US$) of Europe(developing only) in 1998 to that in 2002?
Your response must be concise. 0.61. What is the ratio of the Aid flow (current US$) of Albania in 1998 to that in 2002?
Provide a succinct answer. 2.68. What is the ratio of the Aid flow (current US$) of East Asia (developing only) in 1998 to that in 2003?
Give a very brief answer. 2.1. What is the ratio of the Aid flow (current US$) of Europe(developing only) in 1998 to that in 2003?
Provide a succinct answer. 0.86. What is the ratio of the Aid flow (current US$) in Albania in 1998 to that in 2003?
Offer a very short reply. 1.25. What is the ratio of the Aid flow (current US$) in Guinea-Bissau in 1998 to that in 2003?
Provide a succinct answer. 0.27. What is the ratio of the Aid flow (current US$) of East Asia (developing only) in 1998 to that in 2004?
Your response must be concise. 1.67. What is the ratio of the Aid flow (current US$) of Europe(developing only) in 1998 to that in 2004?
Offer a very short reply. 0.76. What is the ratio of the Aid flow (current US$) in Albania in 1998 to that in 2004?
Provide a short and direct response. 0.91. What is the ratio of the Aid flow (current US$) in Guinea-Bissau in 1998 to that in 2004?
Ensure brevity in your answer.  0.27. What is the ratio of the Aid flow (current US$) in East Asia (developing only) in 1998 to that in 2005?
Your response must be concise. 1.15. What is the ratio of the Aid flow (current US$) of Europe(developing only) in 1998 to that in 2005?
Ensure brevity in your answer.  0.78. What is the ratio of the Aid flow (current US$) of Albania in 1998 to that in 2005?
Keep it short and to the point. 1.1. What is the ratio of the Aid flow (current US$) in Guinea-Bissau in 1998 to that in 2005?
Offer a very short reply. 0.09. What is the ratio of the Aid flow (current US$) in East Asia (developing only) in 1999 to that in 2000?
Provide a succinct answer. 0.68. What is the ratio of the Aid flow (current US$) in Europe(developing only) in 1999 to that in 2000?
Offer a terse response. 1.45. What is the ratio of the Aid flow (current US$) of Albania in 1999 to that in 2000?
Make the answer very short. 3.93. What is the ratio of the Aid flow (current US$) in Guinea-Bissau in 1999 to that in 2000?
Your answer should be compact. 1.67. What is the ratio of the Aid flow (current US$) of East Asia (developing only) in 1999 to that in 2001?
Provide a succinct answer. 0.66. What is the ratio of the Aid flow (current US$) of Europe(developing only) in 1999 to that in 2001?
Offer a very short reply. 1.47. What is the ratio of the Aid flow (current US$) in Albania in 1999 to that in 2001?
Your answer should be compact. 8.21. What is the ratio of the Aid flow (current US$) in Guinea-Bissau in 1999 to that in 2001?
Your answer should be very brief. 2.5. What is the ratio of the Aid flow (current US$) in East Asia (developing only) in 1999 to that in 2002?
Keep it short and to the point. 1.62. What is the ratio of the Aid flow (current US$) of Europe(developing only) in 1999 to that in 2002?
Provide a short and direct response. 0.83. What is the ratio of the Aid flow (current US$) in Albania in 1999 to that in 2002?
Give a very brief answer. 11.04. What is the ratio of the Aid flow (current US$) of Guinea-Bissau in 1999 to that in 2002?
Offer a very short reply. 1.67. What is the ratio of the Aid flow (current US$) in East Asia (developing only) in 1999 to that in 2003?
Give a very brief answer. 1.52. What is the ratio of the Aid flow (current US$) in Europe(developing only) in 1999 to that in 2003?
Provide a succinct answer. 1.17. What is the ratio of the Aid flow (current US$) of Albania in 1999 to that in 2003?
Your answer should be compact. 5.14. What is the ratio of the Aid flow (current US$) of Guinea-Bissau in 1999 to that in 2003?
Provide a succinct answer. 0.45. What is the ratio of the Aid flow (current US$) in East Asia (developing only) in 1999 to that in 2004?
Offer a very short reply. 1.21. What is the ratio of the Aid flow (current US$) of Europe(developing only) in 1999 to that in 2004?
Offer a very short reply. 1.03. What is the ratio of the Aid flow (current US$) of Albania in 1999 to that in 2004?
Make the answer very short. 3.77. What is the ratio of the Aid flow (current US$) of Guinea-Bissau in 1999 to that in 2004?
Ensure brevity in your answer.  0.45. What is the ratio of the Aid flow (current US$) in East Asia (developing only) in 1999 to that in 2005?
Your response must be concise. 0.83. What is the ratio of the Aid flow (current US$) of Europe(developing only) in 1999 to that in 2005?
Your answer should be very brief. 1.06. What is the ratio of the Aid flow (current US$) in Albania in 1999 to that in 2005?
Keep it short and to the point. 4.52. What is the ratio of the Aid flow (current US$) of Guinea-Bissau in 1999 to that in 2005?
Offer a very short reply. 0.14. What is the ratio of the Aid flow (current US$) in East Asia (developing only) in 2000 to that in 2001?
Keep it short and to the point. 0.97. What is the ratio of the Aid flow (current US$) of Europe(developing only) in 2000 to that in 2001?
Provide a short and direct response. 1.02. What is the ratio of the Aid flow (current US$) in Albania in 2000 to that in 2001?
Ensure brevity in your answer.  2.09. What is the ratio of the Aid flow (current US$) of East Asia (developing only) in 2000 to that in 2002?
Provide a succinct answer. 2.4. What is the ratio of the Aid flow (current US$) in Europe(developing only) in 2000 to that in 2002?
Give a very brief answer. 0.58. What is the ratio of the Aid flow (current US$) of Albania in 2000 to that in 2002?
Keep it short and to the point. 2.81. What is the ratio of the Aid flow (current US$) in Guinea-Bissau in 2000 to that in 2002?
Your response must be concise. 1. What is the ratio of the Aid flow (current US$) in East Asia (developing only) in 2000 to that in 2003?
Your answer should be very brief. 2.25. What is the ratio of the Aid flow (current US$) in Europe(developing only) in 2000 to that in 2003?
Ensure brevity in your answer.  0.81. What is the ratio of the Aid flow (current US$) in Albania in 2000 to that in 2003?
Keep it short and to the point. 1.31. What is the ratio of the Aid flow (current US$) of Guinea-Bissau in 2000 to that in 2003?
Your answer should be very brief. 0.27. What is the ratio of the Aid flow (current US$) in East Asia (developing only) in 2000 to that in 2004?
Your response must be concise. 1.8. What is the ratio of the Aid flow (current US$) of Europe(developing only) in 2000 to that in 2004?
Ensure brevity in your answer.  0.71. What is the ratio of the Aid flow (current US$) of Albania in 2000 to that in 2004?
Keep it short and to the point. 0.96. What is the ratio of the Aid flow (current US$) in Guinea-Bissau in 2000 to that in 2004?
Provide a succinct answer. 0.27. What is the ratio of the Aid flow (current US$) of East Asia (developing only) in 2000 to that in 2005?
Give a very brief answer. 1.23. What is the ratio of the Aid flow (current US$) of Europe(developing only) in 2000 to that in 2005?
Keep it short and to the point. 0.73. What is the ratio of the Aid flow (current US$) of Albania in 2000 to that in 2005?
Offer a terse response. 1.15. What is the ratio of the Aid flow (current US$) in Guinea-Bissau in 2000 to that in 2005?
Offer a very short reply. 0.09. What is the ratio of the Aid flow (current US$) in East Asia (developing only) in 2001 to that in 2002?
Ensure brevity in your answer.  2.47. What is the ratio of the Aid flow (current US$) in Europe(developing only) in 2001 to that in 2002?
Keep it short and to the point. 0.57. What is the ratio of the Aid flow (current US$) of Albania in 2001 to that in 2002?
Offer a terse response. 1.34. What is the ratio of the Aid flow (current US$) of East Asia (developing only) in 2001 to that in 2003?
Ensure brevity in your answer.  2.32. What is the ratio of the Aid flow (current US$) of Europe(developing only) in 2001 to that in 2003?
Ensure brevity in your answer.  0.79. What is the ratio of the Aid flow (current US$) in Albania in 2001 to that in 2003?
Provide a succinct answer. 0.63. What is the ratio of the Aid flow (current US$) of Guinea-Bissau in 2001 to that in 2003?
Ensure brevity in your answer.  0.18. What is the ratio of the Aid flow (current US$) in East Asia (developing only) in 2001 to that in 2004?
Keep it short and to the point. 1.85. What is the ratio of the Aid flow (current US$) in Europe(developing only) in 2001 to that in 2004?
Keep it short and to the point. 0.7. What is the ratio of the Aid flow (current US$) in Albania in 2001 to that in 2004?
Offer a terse response. 0.46. What is the ratio of the Aid flow (current US$) of Guinea-Bissau in 2001 to that in 2004?
Offer a very short reply. 0.18. What is the ratio of the Aid flow (current US$) of East Asia (developing only) in 2001 to that in 2005?
Make the answer very short. 1.27. What is the ratio of the Aid flow (current US$) of Europe(developing only) in 2001 to that in 2005?
Ensure brevity in your answer.  0.72. What is the ratio of the Aid flow (current US$) in Albania in 2001 to that in 2005?
Provide a succinct answer. 0.55. What is the ratio of the Aid flow (current US$) of Guinea-Bissau in 2001 to that in 2005?
Give a very brief answer. 0.06. What is the ratio of the Aid flow (current US$) in East Asia (developing only) in 2002 to that in 2003?
Give a very brief answer. 0.94. What is the ratio of the Aid flow (current US$) of Europe(developing only) in 2002 to that in 2003?
Ensure brevity in your answer.  1.4. What is the ratio of the Aid flow (current US$) in Albania in 2002 to that in 2003?
Ensure brevity in your answer.  0.47. What is the ratio of the Aid flow (current US$) in Guinea-Bissau in 2002 to that in 2003?
Your response must be concise. 0.27. What is the ratio of the Aid flow (current US$) in East Asia (developing only) in 2002 to that in 2004?
Offer a very short reply. 0.75. What is the ratio of the Aid flow (current US$) in Europe(developing only) in 2002 to that in 2004?
Your answer should be compact. 1.24. What is the ratio of the Aid flow (current US$) of Albania in 2002 to that in 2004?
Give a very brief answer. 0.34. What is the ratio of the Aid flow (current US$) of Guinea-Bissau in 2002 to that in 2004?
Your answer should be very brief. 0.27. What is the ratio of the Aid flow (current US$) in East Asia (developing only) in 2002 to that in 2005?
Provide a short and direct response. 0.51. What is the ratio of the Aid flow (current US$) of Europe(developing only) in 2002 to that in 2005?
Offer a terse response. 1.28. What is the ratio of the Aid flow (current US$) in Albania in 2002 to that in 2005?
Offer a very short reply. 0.41. What is the ratio of the Aid flow (current US$) in Guinea-Bissau in 2002 to that in 2005?
Your response must be concise. 0.09. What is the ratio of the Aid flow (current US$) of East Asia (developing only) in 2003 to that in 2004?
Provide a short and direct response. 0.8. What is the ratio of the Aid flow (current US$) of Europe(developing only) in 2003 to that in 2004?
Your response must be concise. 0.88. What is the ratio of the Aid flow (current US$) in Albania in 2003 to that in 2004?
Give a very brief answer. 0.73. What is the ratio of the Aid flow (current US$) of Guinea-Bissau in 2003 to that in 2004?
Offer a terse response. 1. What is the ratio of the Aid flow (current US$) of East Asia (developing only) in 2003 to that in 2005?
Your answer should be very brief. 0.55. What is the ratio of the Aid flow (current US$) of Europe(developing only) in 2003 to that in 2005?
Your response must be concise. 0.91. What is the ratio of the Aid flow (current US$) in Albania in 2003 to that in 2005?
Make the answer very short. 0.88. What is the ratio of the Aid flow (current US$) in Guinea-Bissau in 2003 to that in 2005?
Keep it short and to the point. 0.31. What is the ratio of the Aid flow (current US$) in East Asia (developing only) in 2004 to that in 2005?
Provide a short and direct response. 0.69. What is the ratio of the Aid flow (current US$) in Europe(developing only) in 2004 to that in 2005?
Make the answer very short. 1.03. What is the ratio of the Aid flow (current US$) of Albania in 2004 to that in 2005?
Give a very brief answer. 1.2. What is the ratio of the Aid flow (current US$) in Guinea-Bissau in 2004 to that in 2005?
Your answer should be very brief. 0.31. What is the difference between the highest and the second highest Aid flow (current US$) of East Asia (developing only)?
Offer a very short reply. 7.10e+05. What is the difference between the highest and the second highest Aid flow (current US$) of Europe(developing only)?
Provide a succinct answer. 2.50e+07. What is the difference between the highest and the second highest Aid flow (current US$) of Albania?
Your response must be concise. 1.39e+07. What is the difference between the highest and the second highest Aid flow (current US$) in Guinea-Bissau?
Keep it short and to the point. 2.40e+05. What is the difference between the highest and the lowest Aid flow (current US$) of East Asia (developing only)?
Offer a terse response. 1.43e+07. What is the difference between the highest and the lowest Aid flow (current US$) in Europe(developing only)?
Provide a short and direct response. 6.49e+07. What is the difference between the highest and the lowest Aid flow (current US$) of Albania?
Offer a terse response. 1.72e+07. What is the difference between the highest and the lowest Aid flow (current US$) of Guinea-Bissau?
Your answer should be compact. 3.30e+05. 